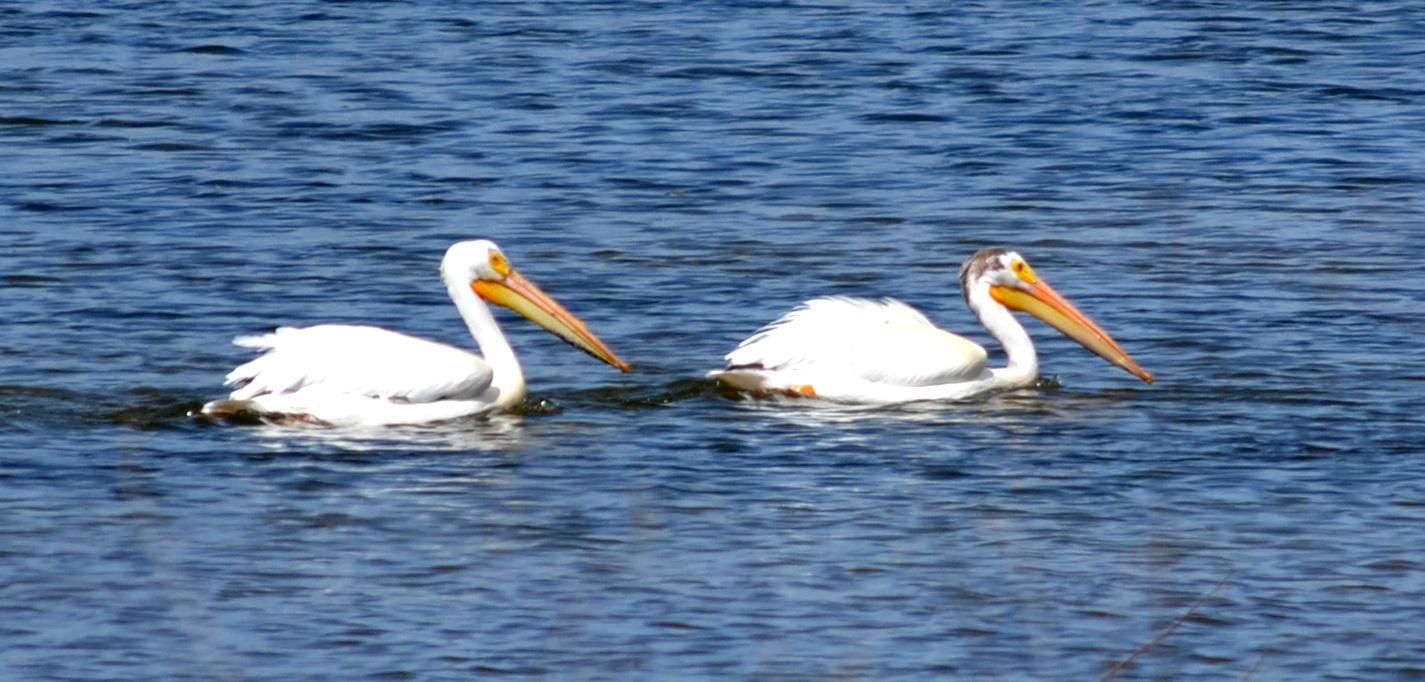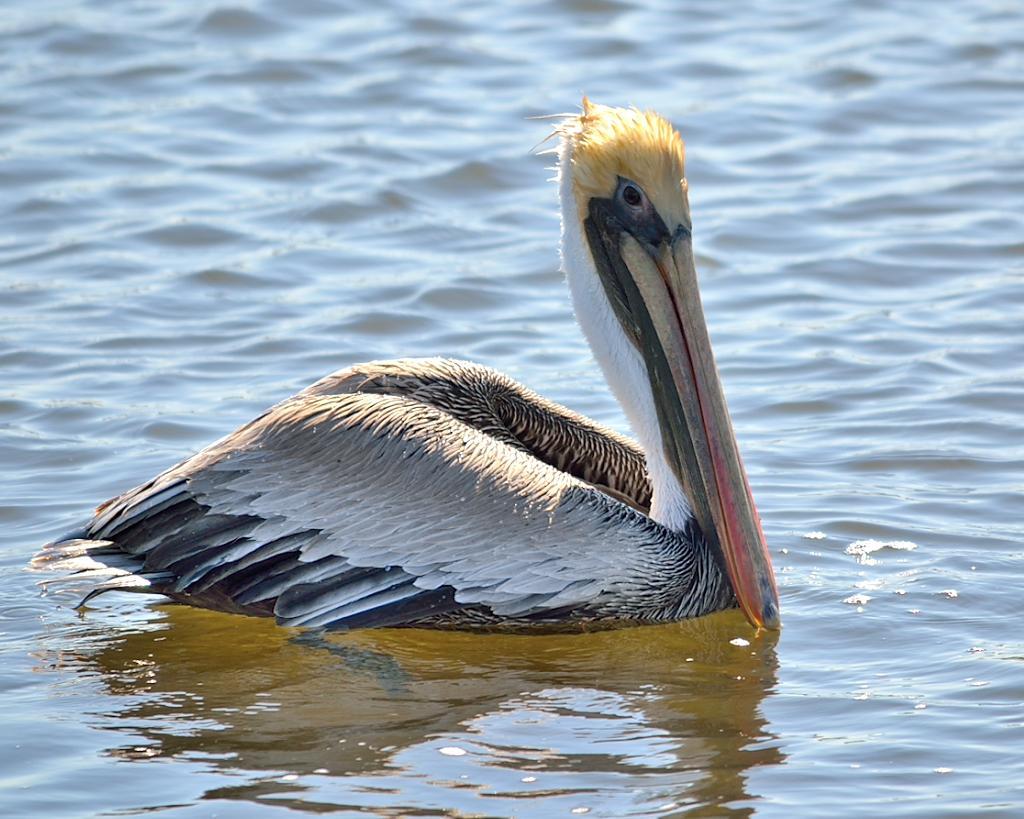The first image is the image on the left, the second image is the image on the right. Examine the images to the left and right. Is the description "There are at least three birds standing on a dock." accurate? Answer yes or no. No. The first image is the image on the left, the second image is the image on the right. Given the left and right images, does the statement "One of the images contains a single bird only." hold true? Answer yes or no. Yes. 